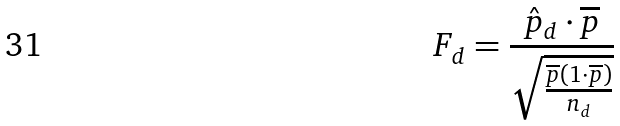Convert formula to latex. <formula><loc_0><loc_0><loc_500><loc_500>F _ { d } = \frac { \hat { p } _ { d } \cdot \overline { p } } { \sqrt { \frac { \overline { p } ( 1 \cdot \overline { p } ) } { n _ { d } } } }</formula> 